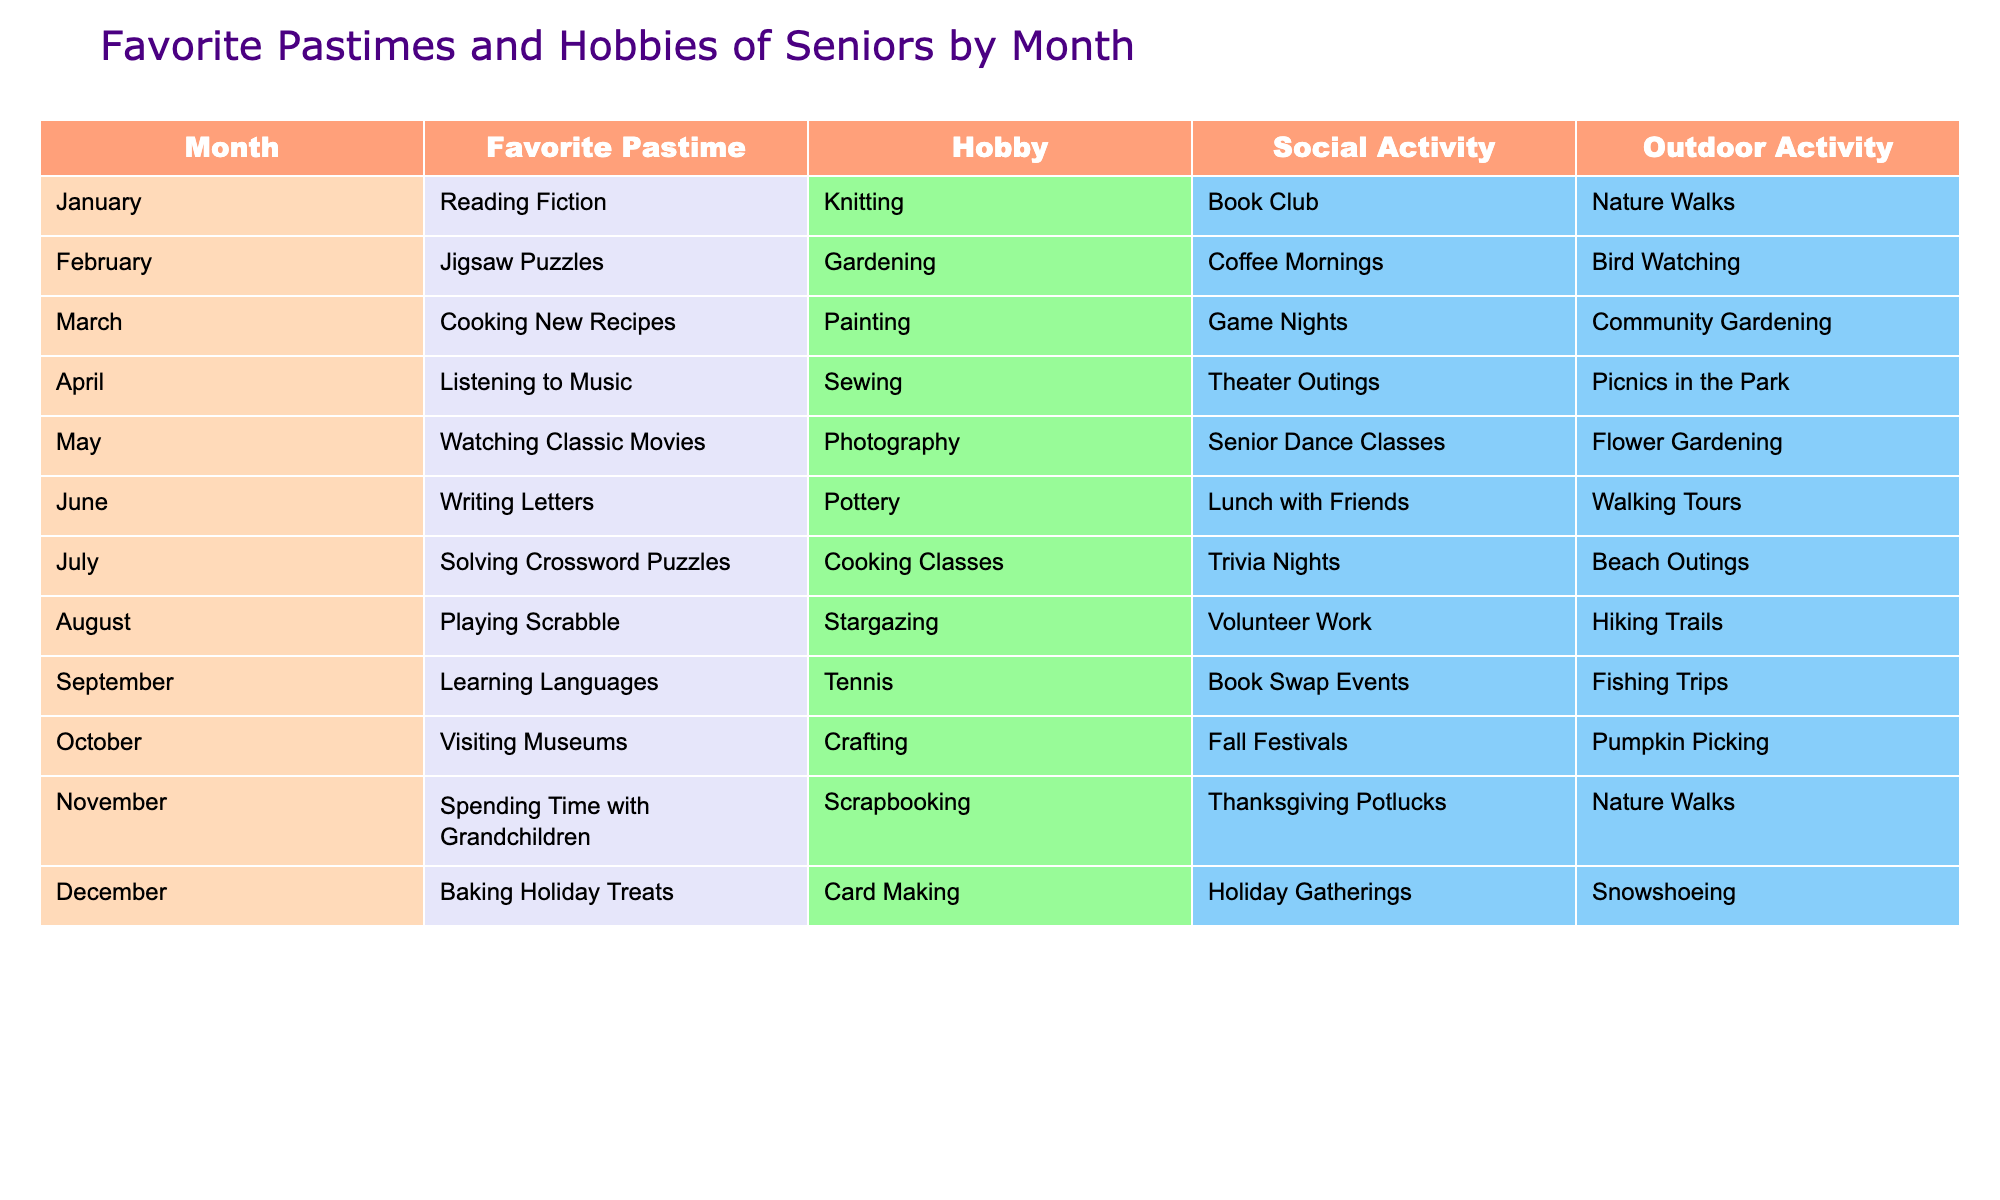What is the favorite pastime of seniors in December? The table shows that in December, the favorite pastime of seniors is "Baking Holiday Treats."
Answer: Baking Holiday Treats Which month features "Game Nights" as a social activity? By looking at the table, we see that "Game Nights" is listed under March as the social activity.
Answer: March In which month do seniors enjoy "Fishing Trips" as their outdoor activity? The table indicates that "Fishing Trips" take place in September as the outdoor activity for that month.
Answer: September How many months feature "Nature Walks" as an outdoor activity? Checking the table, "Nature Walks" appears in January and November, making a total of 2 months.
Answer: 2 What is the social activity for the month of April? The table reveals that the social activity for April is "Theater Outings."
Answer: Theater Outings Which two hobbies are most common in the summer months (June, July, August)? The table lists "Pottery" for June, "Cooking Classes" for July, and "Stargazing" for August. There are three different hobbies across the summer months.
Answer: 3 Is "Sewing" listed as a hobby in the month of February? According to the table, "Sewing" is not listed in February where the hobby is "Gardening."
Answer: No Which month has the largest variety of activities (i.e., the number of distinct pastimes, hobbies, social activities, and outdoor activities)? Looking through each month, December has distinct activities: "Baking Holiday Treats," "Card Making," "Holiday Gatherings," and "Snowshoeing," totaling four unique activities, suggesting it is one of the most varied months.
Answer: December What are the top two outdoor activities enjoyed by seniors in the warmer months (May to August)? Reviewing the table, the outdoor activities for these months are "Flower Gardening" in May, "Beach Outings" in July, and "Hiking Trails" in August, giving us three distinct outdoor activities across these months.
Answer: 3 If a senior participates in "Trivia Nights" in July and "Stargazing" in August, how many different social activities do they engage in during those two months? The table lists "Trivia Nights" for July and "Volunteer Work" for August, indicating 2 different social activities are engaged during those months.
Answer: 2 